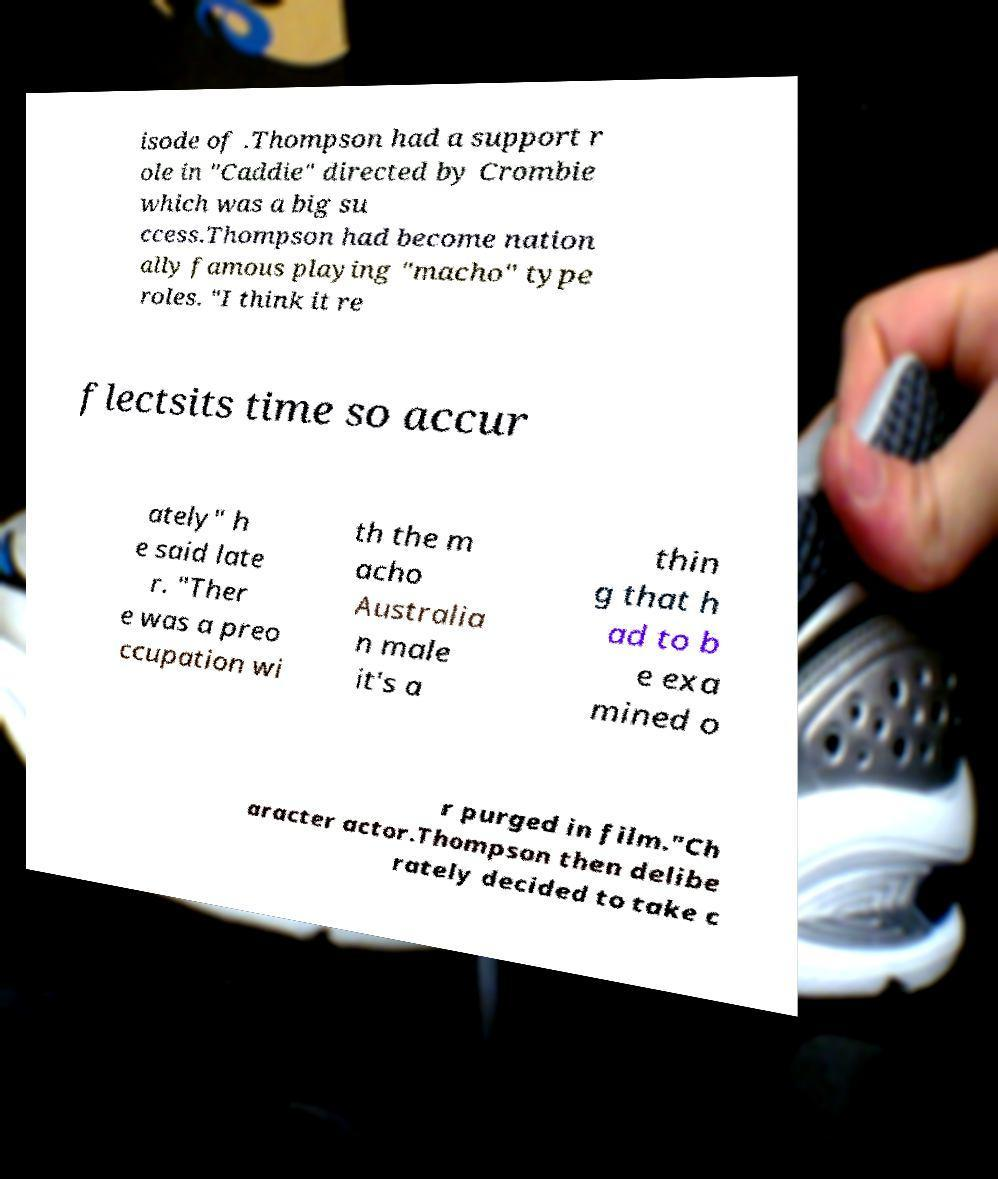Can you accurately transcribe the text from the provided image for me? isode of .Thompson had a support r ole in "Caddie" directed by Crombie which was a big su ccess.Thompson had become nation ally famous playing "macho" type roles. "I think it re flectsits time so accur ately" h e said late r. "Ther e was a preo ccupation wi th the m acho Australia n male it's a thin g that h ad to b e exa mined o r purged in film."Ch aracter actor.Thompson then delibe rately decided to take c 